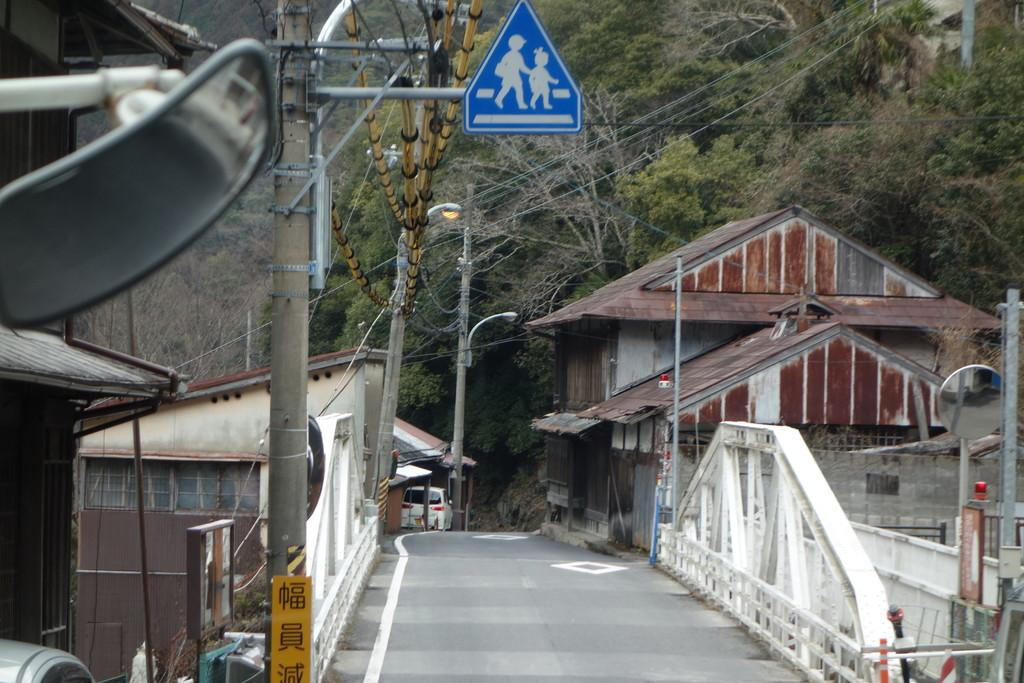What is located in the center of the image? In the center of the image, there are poles, sign boards, mirrors, banners, fences, and vehicles. Can you describe the objects in the center of the image? The objects in the center of the image include poles, sign boards, mirrors, banners, fences, and vehicles. What can be seen in the background of the image? In the background of the image, there are trees and buildings. What type of amusement machine is present in the image? There is no amusement machine present in the image. What is the stick used for in the image? There is no stick present in the image. 